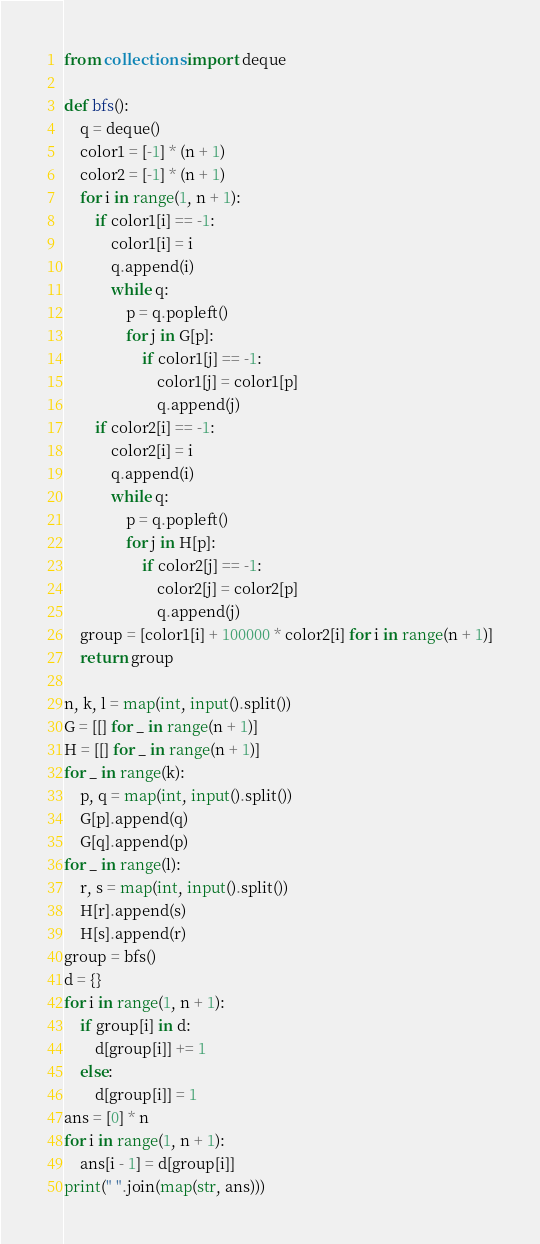Convert code to text. <code><loc_0><loc_0><loc_500><loc_500><_Python_>from collections import deque

def bfs():
    q = deque()
    color1 = [-1] * (n + 1)
    color2 = [-1] * (n + 1)
    for i in range(1, n + 1):
        if color1[i] == -1:
            color1[i] = i
            q.append(i)
            while q:
                p = q.popleft()
                for j in G[p]:
                    if color1[j] == -1:
                        color1[j] = color1[p]
                        q.append(j)
        if color2[i] == -1:
            color2[i] = i
            q.append(i)
            while q:
                p = q.popleft()
                for j in H[p]:
                    if color2[j] == -1:
                        color2[j] = color2[p]
                        q.append(j)
    group = [color1[i] + 100000 * color2[i] for i in range(n + 1)]
    return group

n, k, l = map(int, input().split())
G = [[] for _ in range(n + 1)]
H = [[] for _ in range(n + 1)]
for _ in range(k):
    p, q = map(int, input().split())
    G[p].append(q)
    G[q].append(p)
for _ in range(l):
    r, s = map(int, input().split())
    H[r].append(s)
    H[s].append(r)
group = bfs()
d = {}
for i in range(1, n + 1):
    if group[i] in d:
        d[group[i]] += 1
    else:
        d[group[i]] = 1
ans = [0] * n
for i in range(1, n + 1):
    ans[i - 1] = d[group[i]]
print(" ".join(map(str, ans)))</code> 